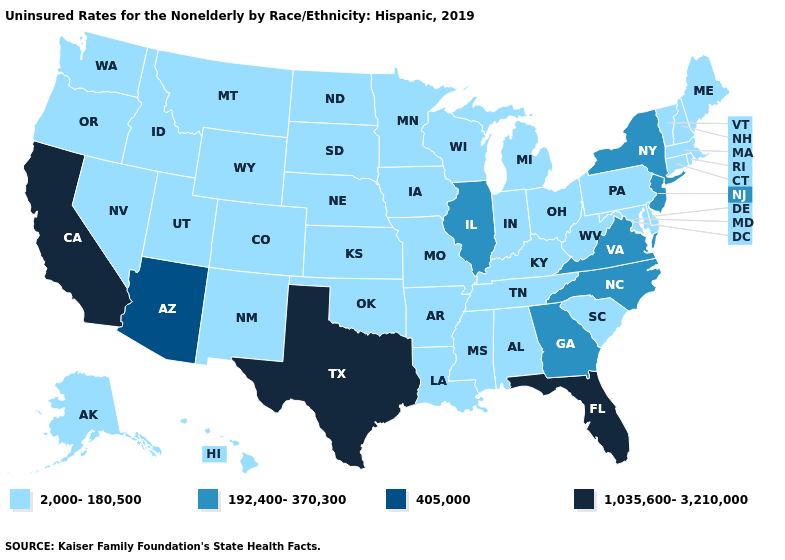Does Virginia have the lowest value in the USA?
Keep it brief. No. What is the lowest value in the South?
Short answer required. 2,000-180,500. What is the value of Washington?
Keep it brief. 2,000-180,500. Which states have the lowest value in the MidWest?
Give a very brief answer. Indiana, Iowa, Kansas, Michigan, Minnesota, Missouri, Nebraska, North Dakota, Ohio, South Dakota, Wisconsin. Which states have the lowest value in the Northeast?
Give a very brief answer. Connecticut, Maine, Massachusetts, New Hampshire, Pennsylvania, Rhode Island, Vermont. Among the states that border Indiana , which have the lowest value?
Quick response, please. Kentucky, Michigan, Ohio. Does Indiana have the highest value in the MidWest?
Keep it brief. No. What is the value of Rhode Island?
Quick response, please. 2,000-180,500. Which states hav the highest value in the MidWest?
Write a very short answer. Illinois. Does Arizona have the lowest value in the West?
Concise answer only. No. What is the highest value in the USA?
Keep it brief. 1,035,600-3,210,000. What is the value of Virginia?
Short answer required. 192,400-370,300. Does Arizona have the lowest value in the West?
Short answer required. No. How many symbols are there in the legend?
Keep it brief. 4. Does the first symbol in the legend represent the smallest category?
Answer briefly. Yes. 